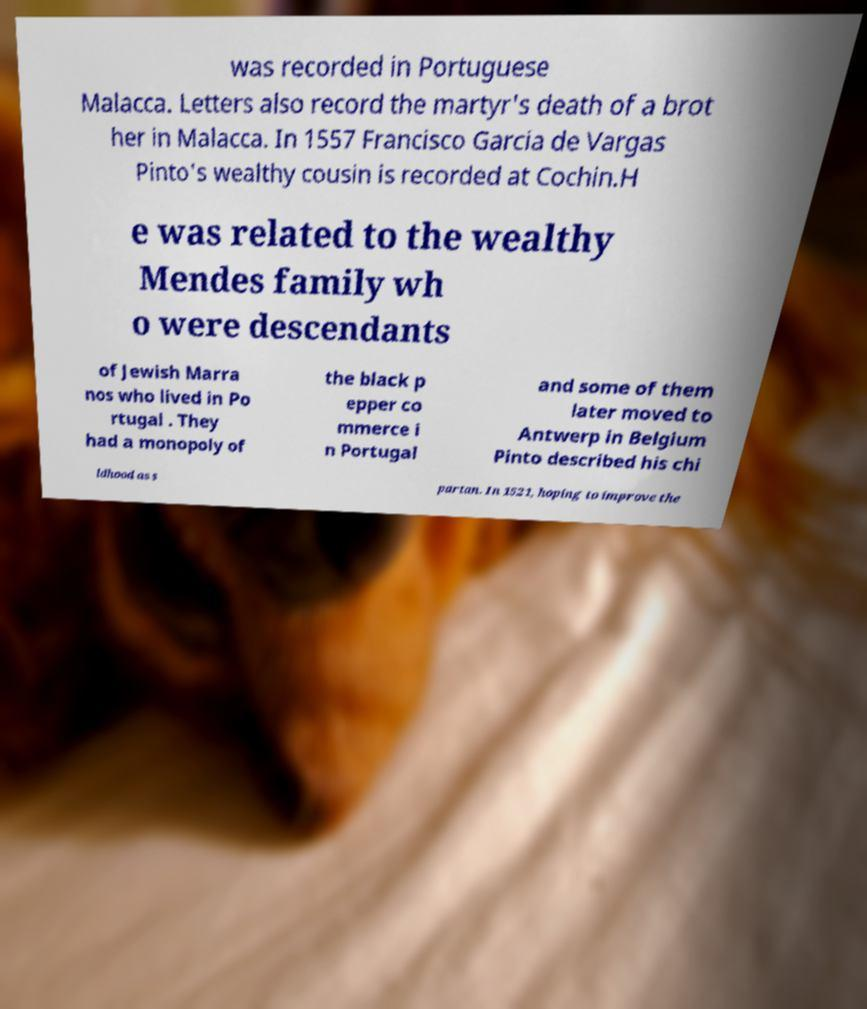What messages or text are displayed in this image? I need them in a readable, typed format. was recorded in Portuguese Malacca. Letters also record the martyr's death of a brot her in Malacca. In 1557 Francisco Garcia de Vargas Pinto's wealthy cousin is recorded at Cochin.H e was related to the wealthy Mendes family wh o were descendants of Jewish Marra nos who lived in Po rtugal . They had a monopoly of the black p epper co mmerce i n Portugal and some of them later moved to Antwerp in Belgium Pinto described his chi ldhood as s partan. In 1521, hoping to improve the 